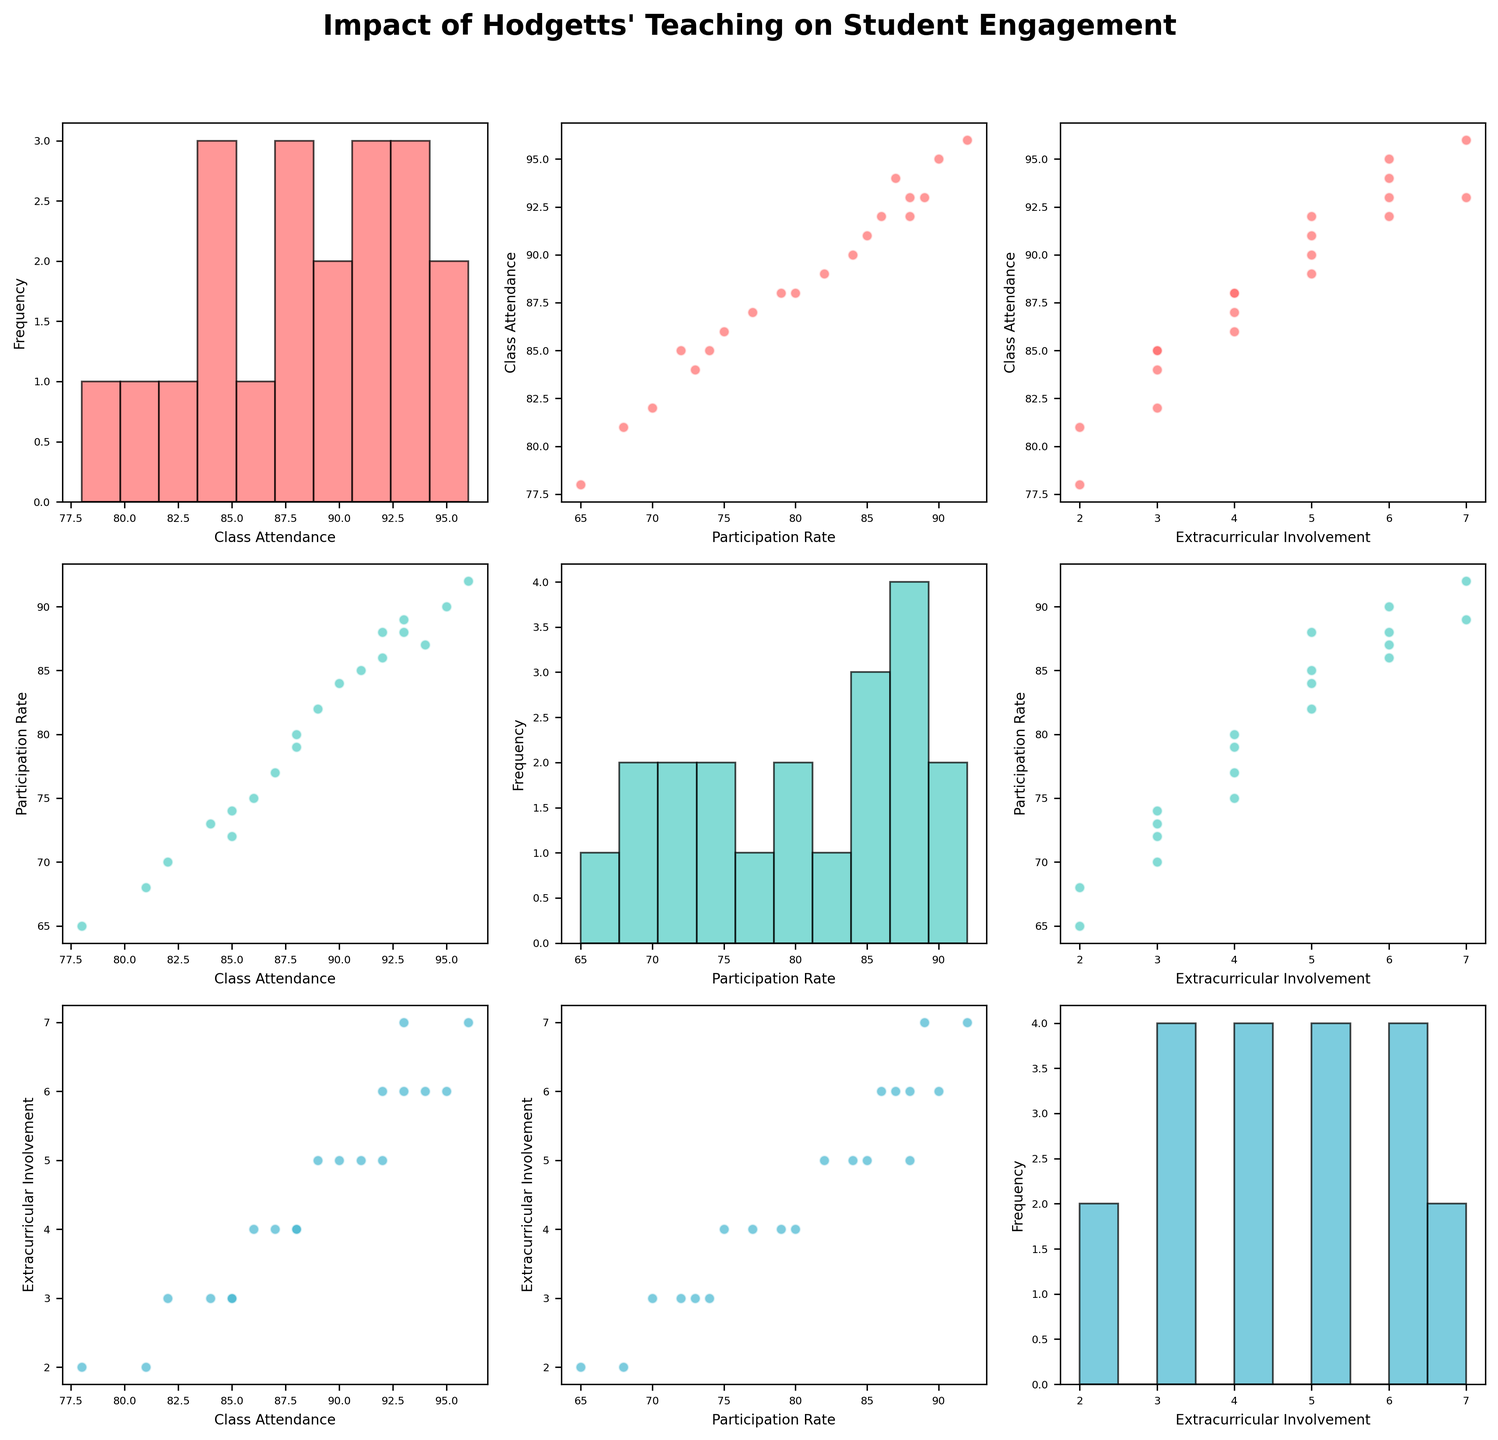What is the main title of the figure? The main title can be found at the top of the figure. It is usually in larger and bold font for emphasis.
Answer: Impact of Hodgetts' Teaching on Student Engagement How many data points are there in each scatterplot? Each scatterplot represents every student's data in the dataset. There are 20 students in total, so each scatter plot contains 20 points.
Answer: 20 Which variable has the highest frequency in its histogram? By comparing the peaks of the histograms along the diagonal, the variable with the highest peak represents the highest frequency. Participation Rate seems to have a histogram with a higher peak compared to the others.
Answer: Participation Rate Is there a positive correlation between Class Attendance and Participation Rate? We observe the scatter plot where Class Attendance is on the y-axis and Participation Rate is on the x-axis. A positive correlation is indicated by an upward trend in the scatter plot.
Answer: Yes What is the color used for visualizing Participation Rate in the scatter plot matrix? The colors are indicated in a custom palette, and Participation Rate is the second variable. The second color in the custom color palette (‘#4ECDC4’) is used for Participation Rate.
Answer: Teal/Light Green Do students who attend class more also participate more? This question examines the scatterplot of Class Attendance versus Participation Rate. A positive trend in this scatterplot would show that higher attendance associates with higher participation.
Answer: Yes Which pair of variables seems to have the strongest relationship based on the scatter plots? We compare the trends and tightness of the scatter points in each pair of variables. The stronger the relationship, the more consistent the trend line looks. The scatter plot of Class Attendance versus Participation Rate seems to have a very strong positive trend.
Answer: Class Attendance and Participation Rate Are there any students with low class attendance but high extracurricular involvement? We identify points in the scatter plot of Extracurricular Involvement vs. Class Attendance that are towards the low end of Class Attendance but high in Extracurricular Involvement. Students on the lower end of Class Attendance axis with higher values on Extracurricular Involvement indicate this scenario.
Answer: Yes What is the relationship between Class Attendance and Extracurricular Involvement? We observe the scatter plot where Class Attendance is on the y-axis and Extracurricular Involvement is on the x-axis. If there is an upward trend, they are positively correlated; if it is downward, they are negatively correlated. The plot seems to show a slight positive correlation.
Answer: Slight positive correlation Considering Participation Rate and Extracurricular Involvement, do students who participate more in class also engage more in extracurricular activities? We look at the scatter plot where Participation Rate is on the y-axis and Extracurricular Involvement is on the x-axis. A positive correlation suggests that students who participate more in class are also involved in more extracurricular activities.
Answer: Yes 